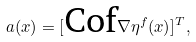<formula> <loc_0><loc_0><loc_500><loc_500>a ( x ) = [ \text {Cof} \nabla \eta ^ { f } ( x ) ] ^ { T } ,</formula> 